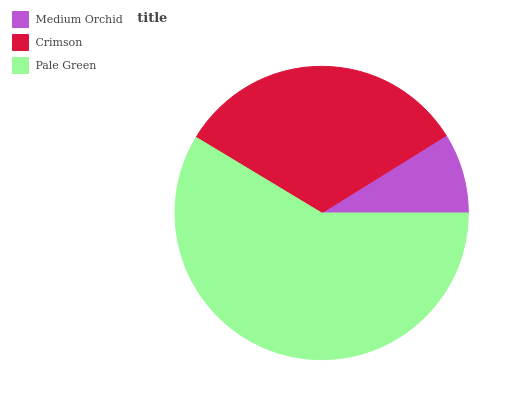Is Medium Orchid the minimum?
Answer yes or no. Yes. Is Pale Green the maximum?
Answer yes or no. Yes. Is Crimson the minimum?
Answer yes or no. No. Is Crimson the maximum?
Answer yes or no. No. Is Crimson greater than Medium Orchid?
Answer yes or no. Yes. Is Medium Orchid less than Crimson?
Answer yes or no. Yes. Is Medium Orchid greater than Crimson?
Answer yes or no. No. Is Crimson less than Medium Orchid?
Answer yes or no. No. Is Crimson the high median?
Answer yes or no. Yes. Is Crimson the low median?
Answer yes or no. Yes. Is Medium Orchid the high median?
Answer yes or no. No. Is Medium Orchid the low median?
Answer yes or no. No. 